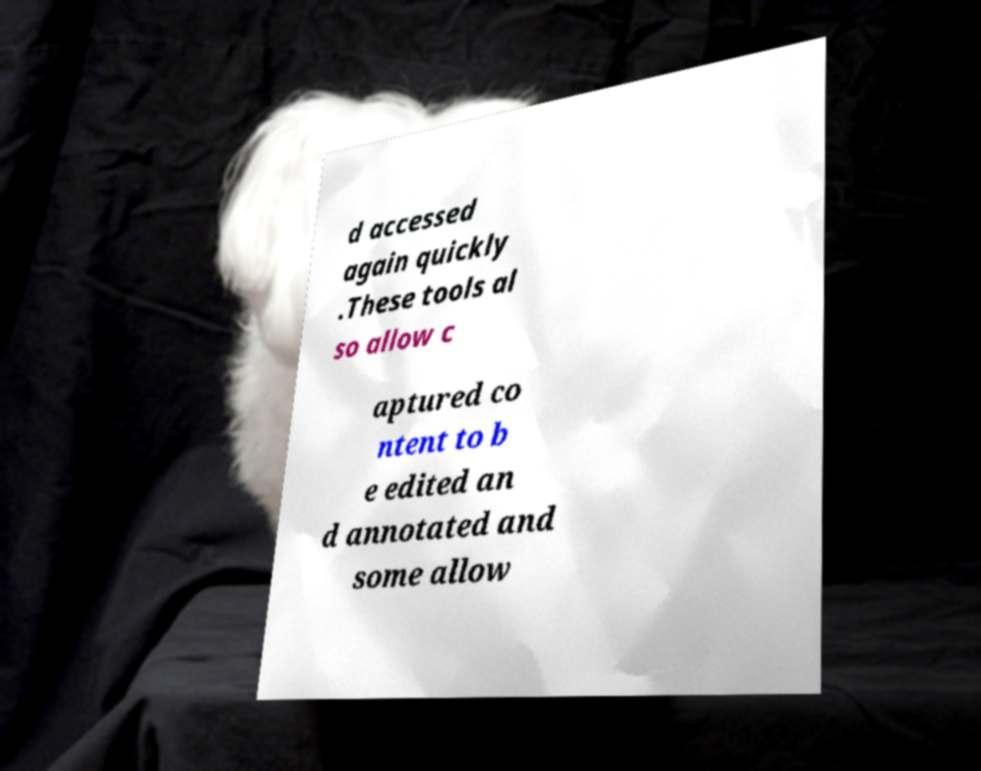I need the written content from this picture converted into text. Can you do that? d accessed again quickly .These tools al so allow c aptured co ntent to b e edited an d annotated and some allow 